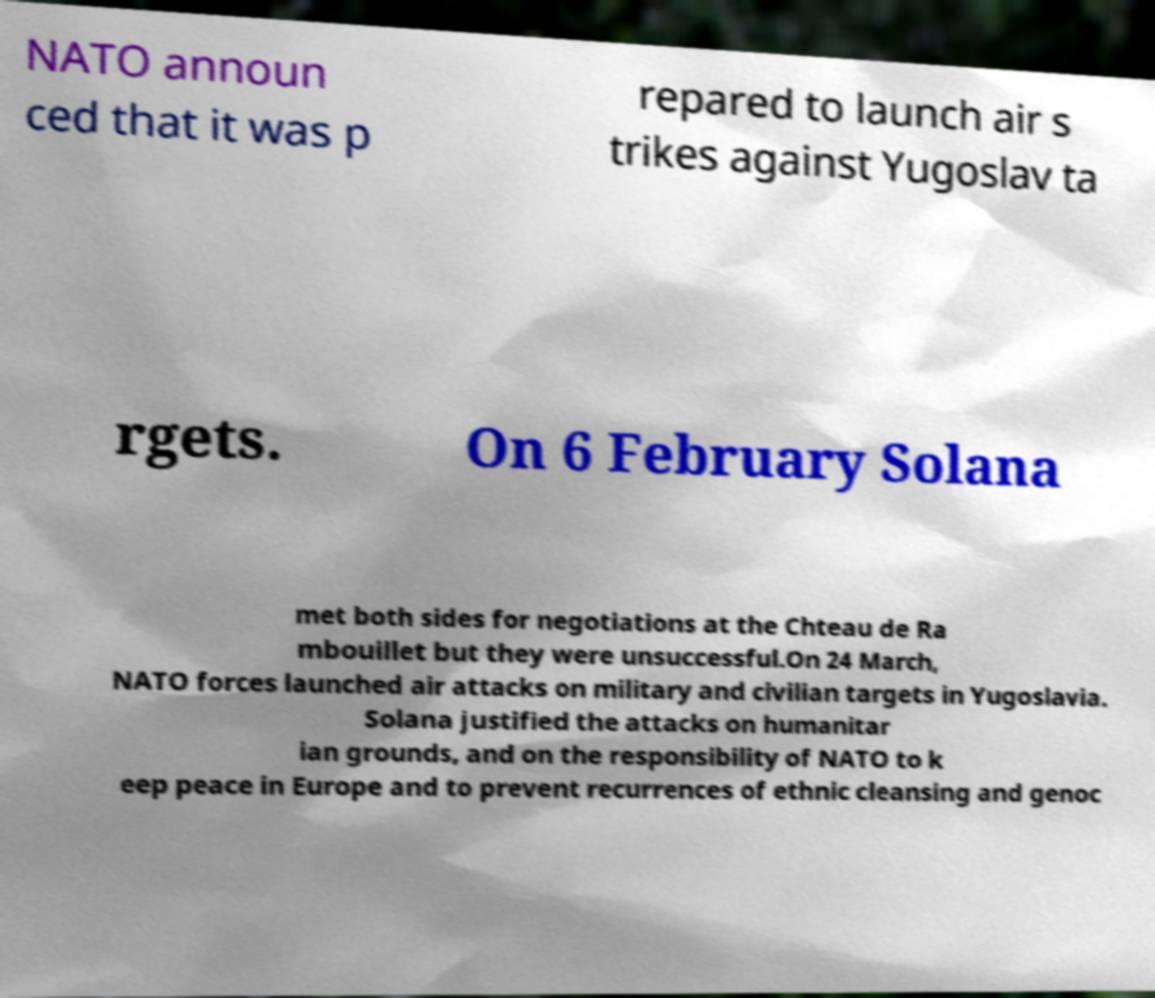I need the written content from this picture converted into text. Can you do that? NATO announ ced that it was p repared to launch air s trikes against Yugoslav ta rgets. On 6 February Solana met both sides for negotiations at the Chteau de Ra mbouillet but they were unsuccessful.On 24 March, NATO forces launched air attacks on military and civilian targets in Yugoslavia. Solana justified the attacks on humanitar ian grounds, and on the responsibility of NATO to k eep peace in Europe and to prevent recurrences of ethnic cleansing and genoc 